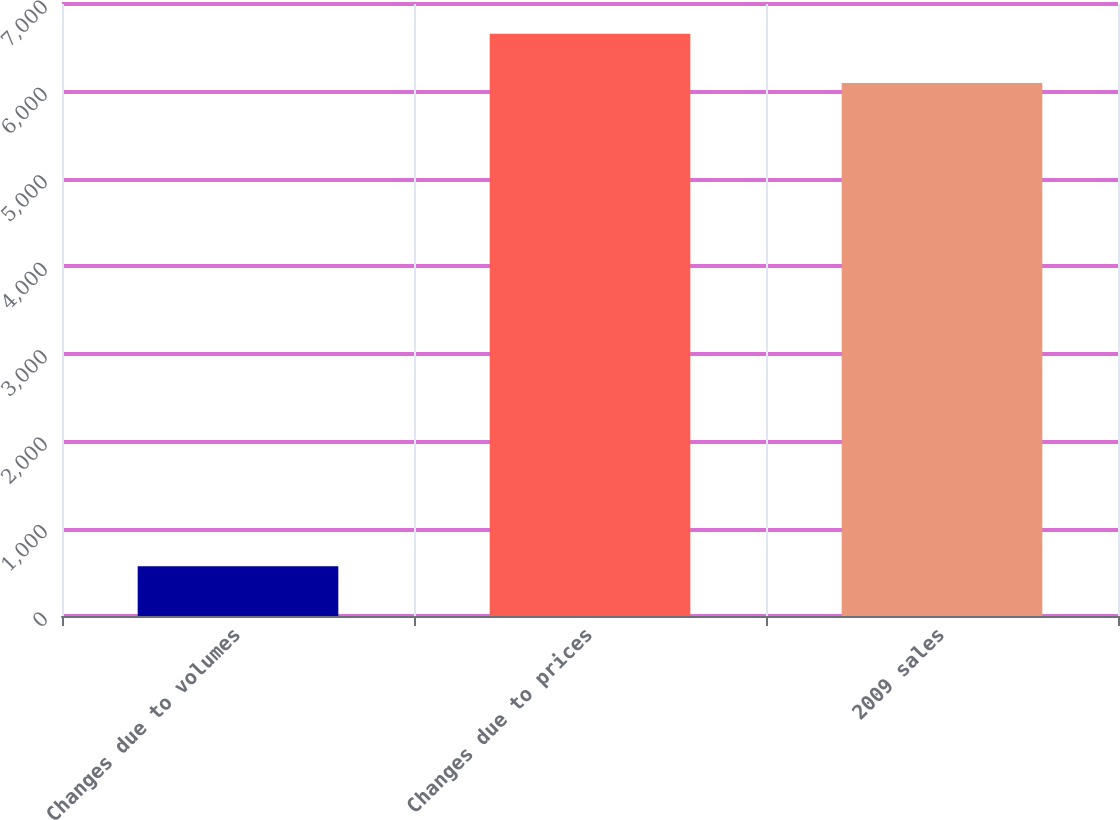<chart> <loc_0><loc_0><loc_500><loc_500><bar_chart><fcel>Changes due to volumes<fcel>Changes due to prices<fcel>2009 sales<nl><fcel>569<fcel>6659.3<fcel>6097<nl></chart> 